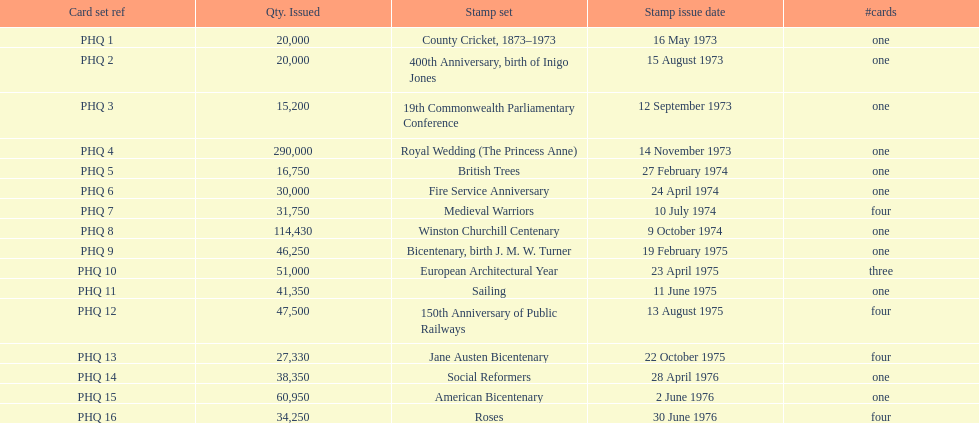Which was the only stamp set to have more than 200,000 issued? Royal Wedding (The Princess Anne). 